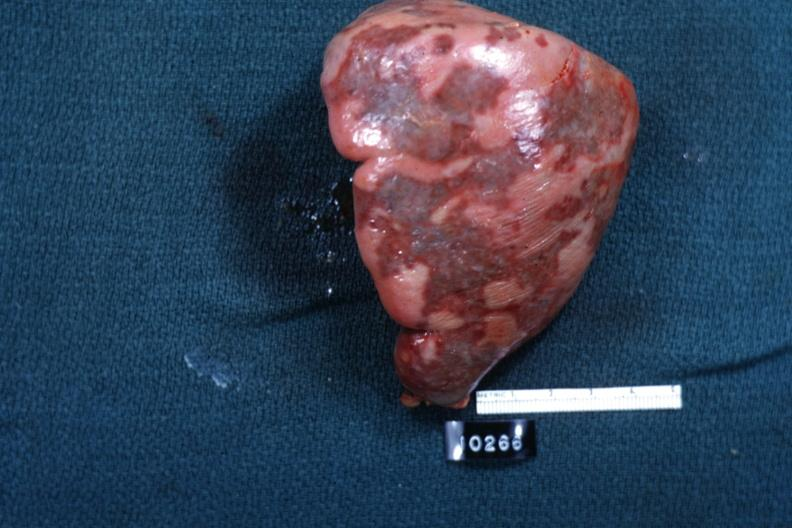what cut surface is slide?
Answer the question using a single word or phrase. External view of spleen with multiple recent infarcts 